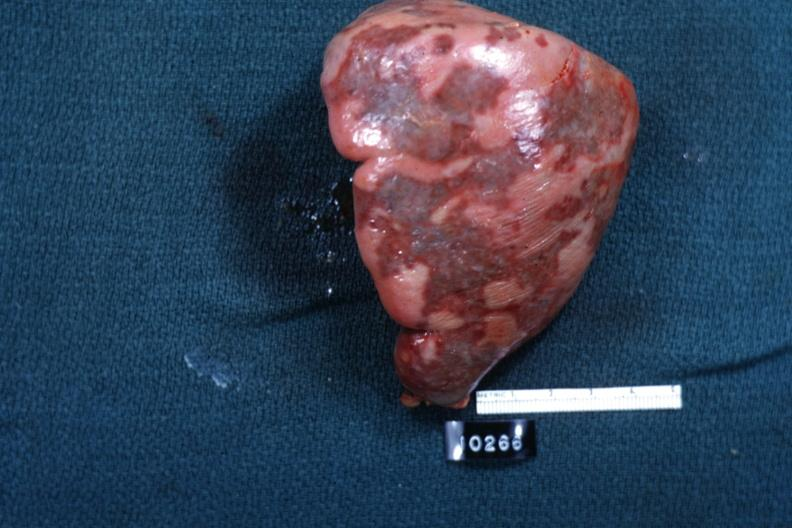what cut surface is slide?
Answer the question using a single word or phrase. External view of spleen with multiple recent infarcts 